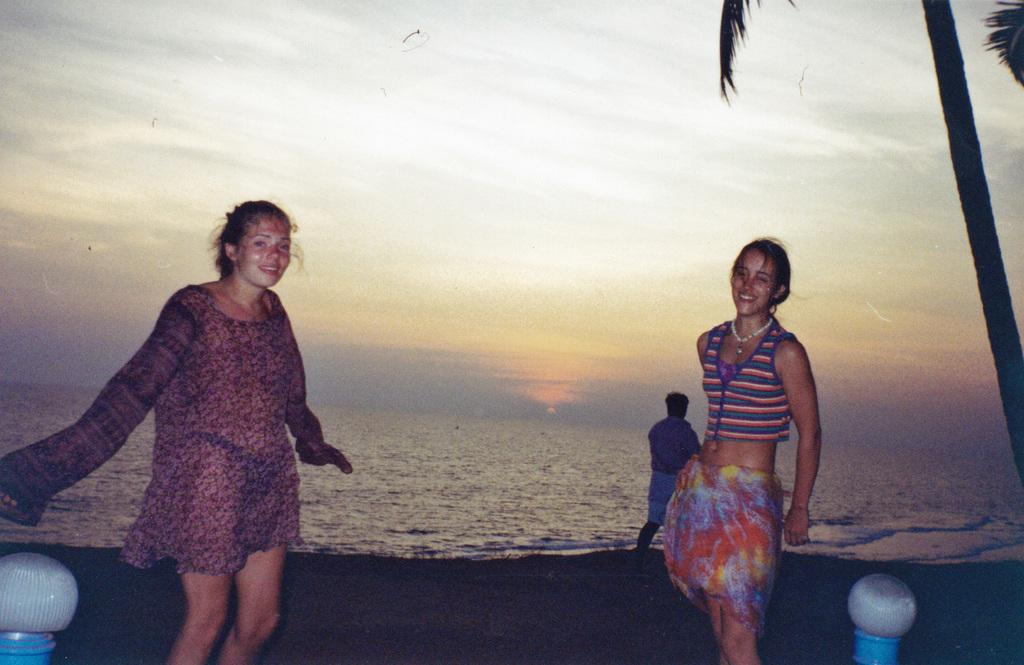How many women are present in the image? There are two women standing in the image. What can be seen in the background of the image? There is a tree, a person, water, and the sky visible in the background of the image. What color is the orange hanging from the tree in the image? There is no orange present in the image; it only features a tree and other elements mentioned in the facts. 